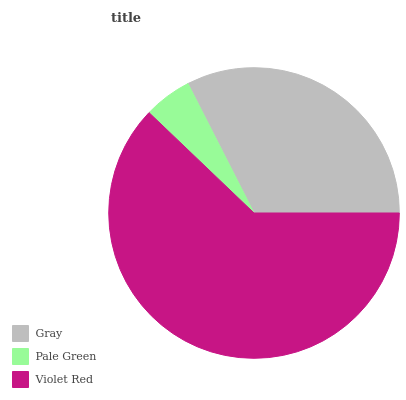Is Pale Green the minimum?
Answer yes or no. Yes. Is Violet Red the maximum?
Answer yes or no. Yes. Is Violet Red the minimum?
Answer yes or no. No. Is Pale Green the maximum?
Answer yes or no. No. Is Violet Red greater than Pale Green?
Answer yes or no. Yes. Is Pale Green less than Violet Red?
Answer yes or no. Yes. Is Pale Green greater than Violet Red?
Answer yes or no. No. Is Violet Red less than Pale Green?
Answer yes or no. No. Is Gray the high median?
Answer yes or no. Yes. Is Gray the low median?
Answer yes or no. Yes. Is Pale Green the high median?
Answer yes or no. No. Is Violet Red the low median?
Answer yes or no. No. 